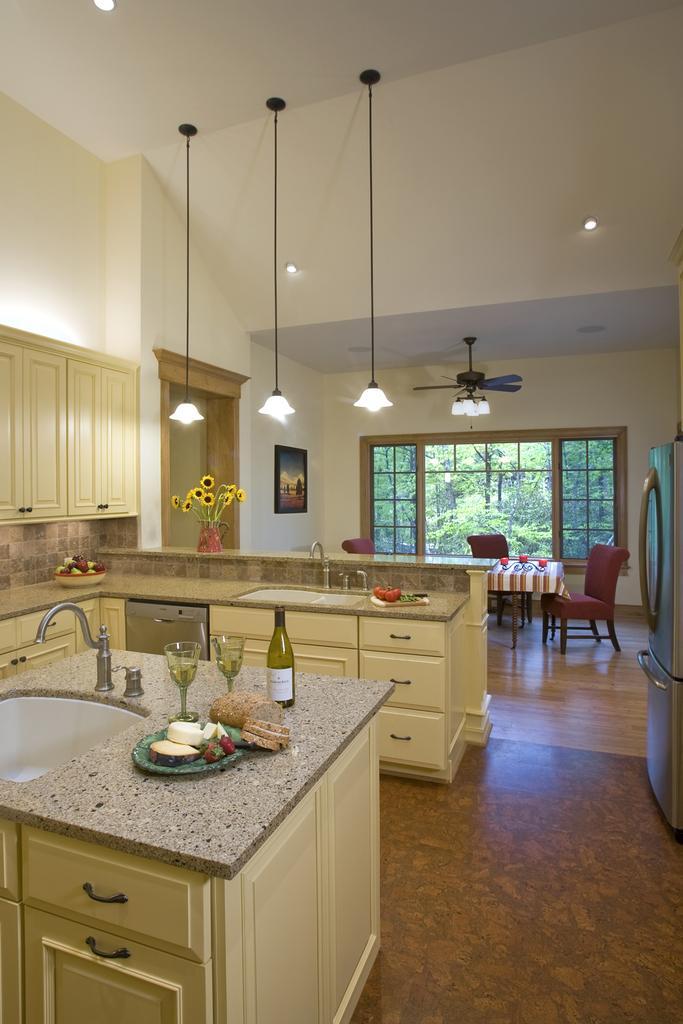Could you give a brief overview of what you see in this image? This Image is clicked in a room. It consists of window, countertop, sink, cupboard. On counter top there are two glasses ,one bottle and eatables and there is a flower vase. There are lights ,there is a dining table, there are chairs and there is a refrigerator On the right side ,on the left side there are cupboards. On the top there are lights. 